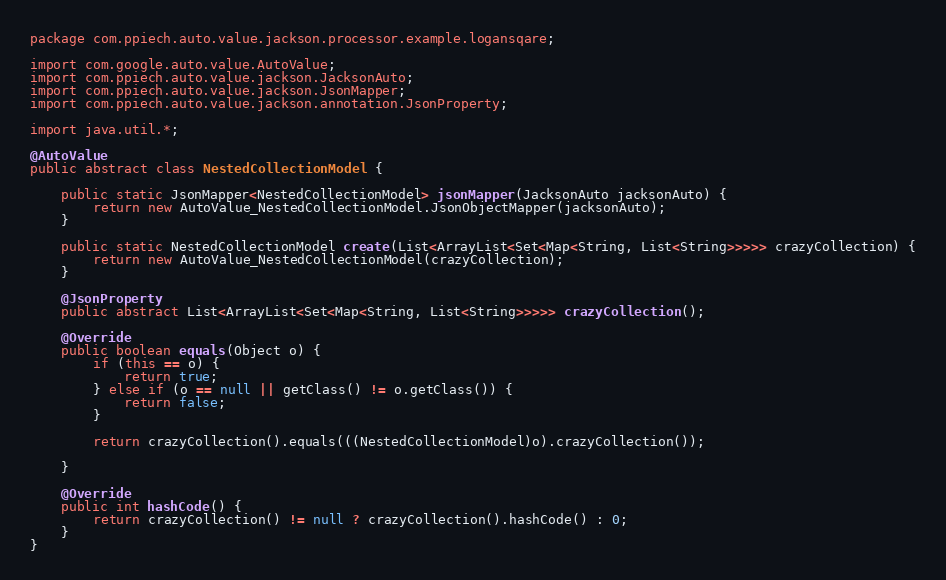Convert code to text. <code><loc_0><loc_0><loc_500><loc_500><_Java_>package com.ppiech.auto.value.jackson.processor.example.logansqare;

import com.google.auto.value.AutoValue;
import com.ppiech.auto.value.jackson.JacksonAuto;
import com.ppiech.auto.value.jackson.JsonMapper;
import com.ppiech.auto.value.jackson.annotation.JsonProperty;

import java.util.*;

@AutoValue
public abstract class NestedCollectionModel {

    public static JsonMapper<NestedCollectionModel> jsonMapper(JacksonAuto jacksonAuto) {
        return new AutoValue_NestedCollectionModel.JsonObjectMapper(jacksonAuto);
    }

    public static NestedCollectionModel create(List<ArrayList<Set<Map<String, List<String>>>>> crazyCollection) {
        return new AutoValue_NestedCollectionModel(crazyCollection);
    }

    @JsonProperty
    public abstract List<ArrayList<Set<Map<String, List<String>>>>> crazyCollection();

    @Override
    public boolean equals(Object o) {
        if (this == o) {
            return true;
        } else if (o == null || getClass() != o.getClass()) {
            return false;
        }

        return crazyCollection().equals(((NestedCollectionModel)o).crazyCollection());

    }

    @Override
    public int hashCode() {
        return crazyCollection() != null ? crazyCollection().hashCode() : 0;
    }
}
</code> 